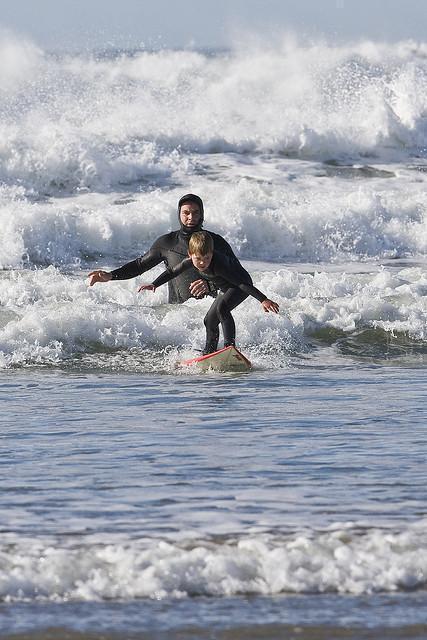Why are they dressed in black?
Make your selection from the four choices given to correctly answer the question.
Options: Fashionable, lack money, easier spotting, wetsuits. Wetsuits. 